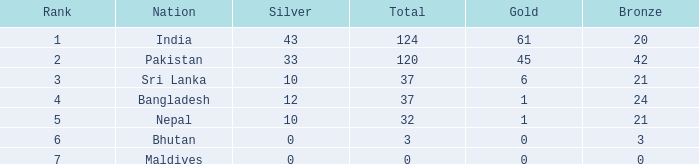Which gold's rank is less than 5 and has 20 bronze? 61.0. 